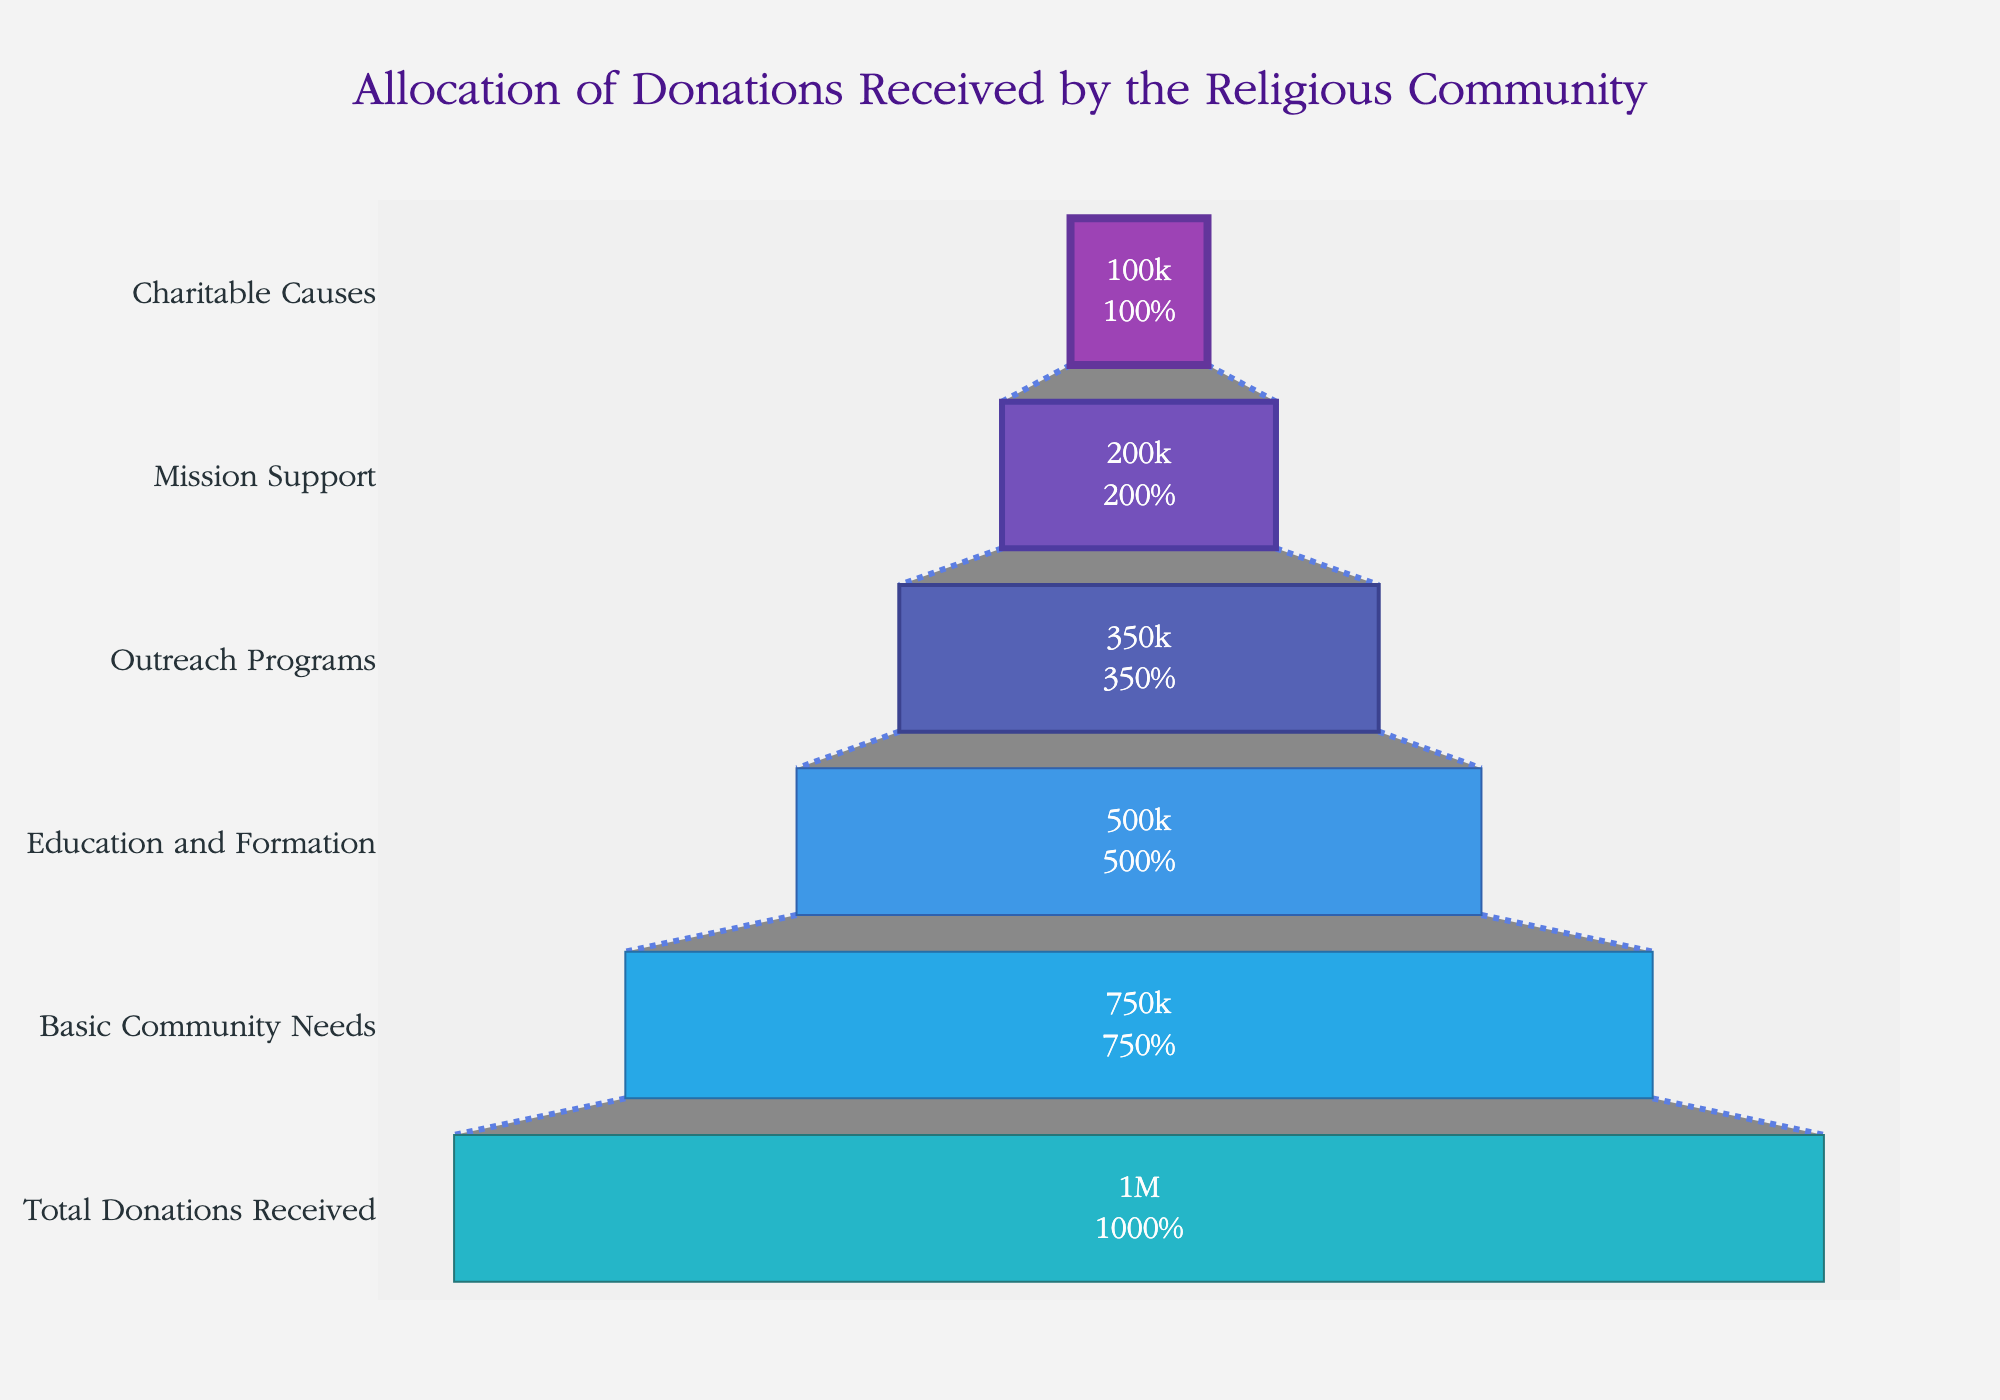What's the title of the figure? The title is displayed at the top center of the figure in a large, distinctive font.
Answer: Allocation of Donations Received by the Religious Community What is the total amount allocated to Basic Community Needs? The Basic Community Needs category shows the amount allocated at the corresponding segment in the funnel chart.
Answer: 750000 Which category has the smallest allocation? By comparing the lengths of the segments, the smallest segment represents the category with the smallest allocation.
Answer: Charitable Causes How much more is allocated to Mission Support than to Charitable Causes? Subtract the amount allocated to Charitable Causes from the amount allocated to Mission Support: 200000 - 100000.
Answer: 100000 What percentage of the total donations is allocated to Education and Formation? Education and Formation's amount is shown, and it represents 50% of the initial total donations received in the figure.
Answer: 50% What is the combined allocation for Outreach Programs and Mission Support? Add the amounts for Outreach Programs and Mission Support: 350000 + 200000.
Answer: 550000 Which category sees a reduction that is exactly half of the Basic Community Needs allocation? Compare the amounts to find that Education and Formation (500000) is exactly half of Basic Community Needs' allocation (750000).
Answer: Education and Formation Which segment of the funnel is directly above the Outreach Programs segment? The segment above Outreach Programs in the funnel chart is Education and Formation.
Answer: Education and Formation How much less is allocated to Outreach Programs compared to Basic Community Needs? Subtract the amount allocated to Outreach Programs from Basic Community Needs: 750000 - 350000.
Answer: 400000 Rank the categories from highest to lowest allocation. Listing the categories by their respective amount values in descending order.
Answer: Basic Community Needs, Education and Formation, Outreach Programs, Mission Support, Charitable Causes 